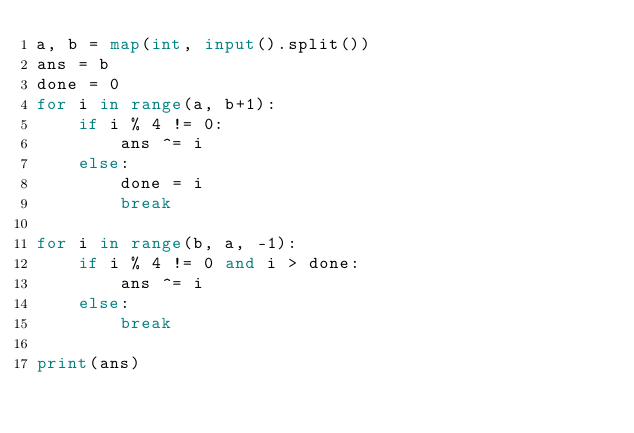Convert code to text. <code><loc_0><loc_0><loc_500><loc_500><_Python_>a, b = map(int, input().split())
ans = b
done = 0
for i in range(a, b+1):
    if i % 4 != 0:
        ans ^= i
    else:
        done = i
        break

for i in range(b, a, -1):
    if i % 4 != 0 and i > done:
        ans ^= i
    else:
        break

print(ans)</code> 